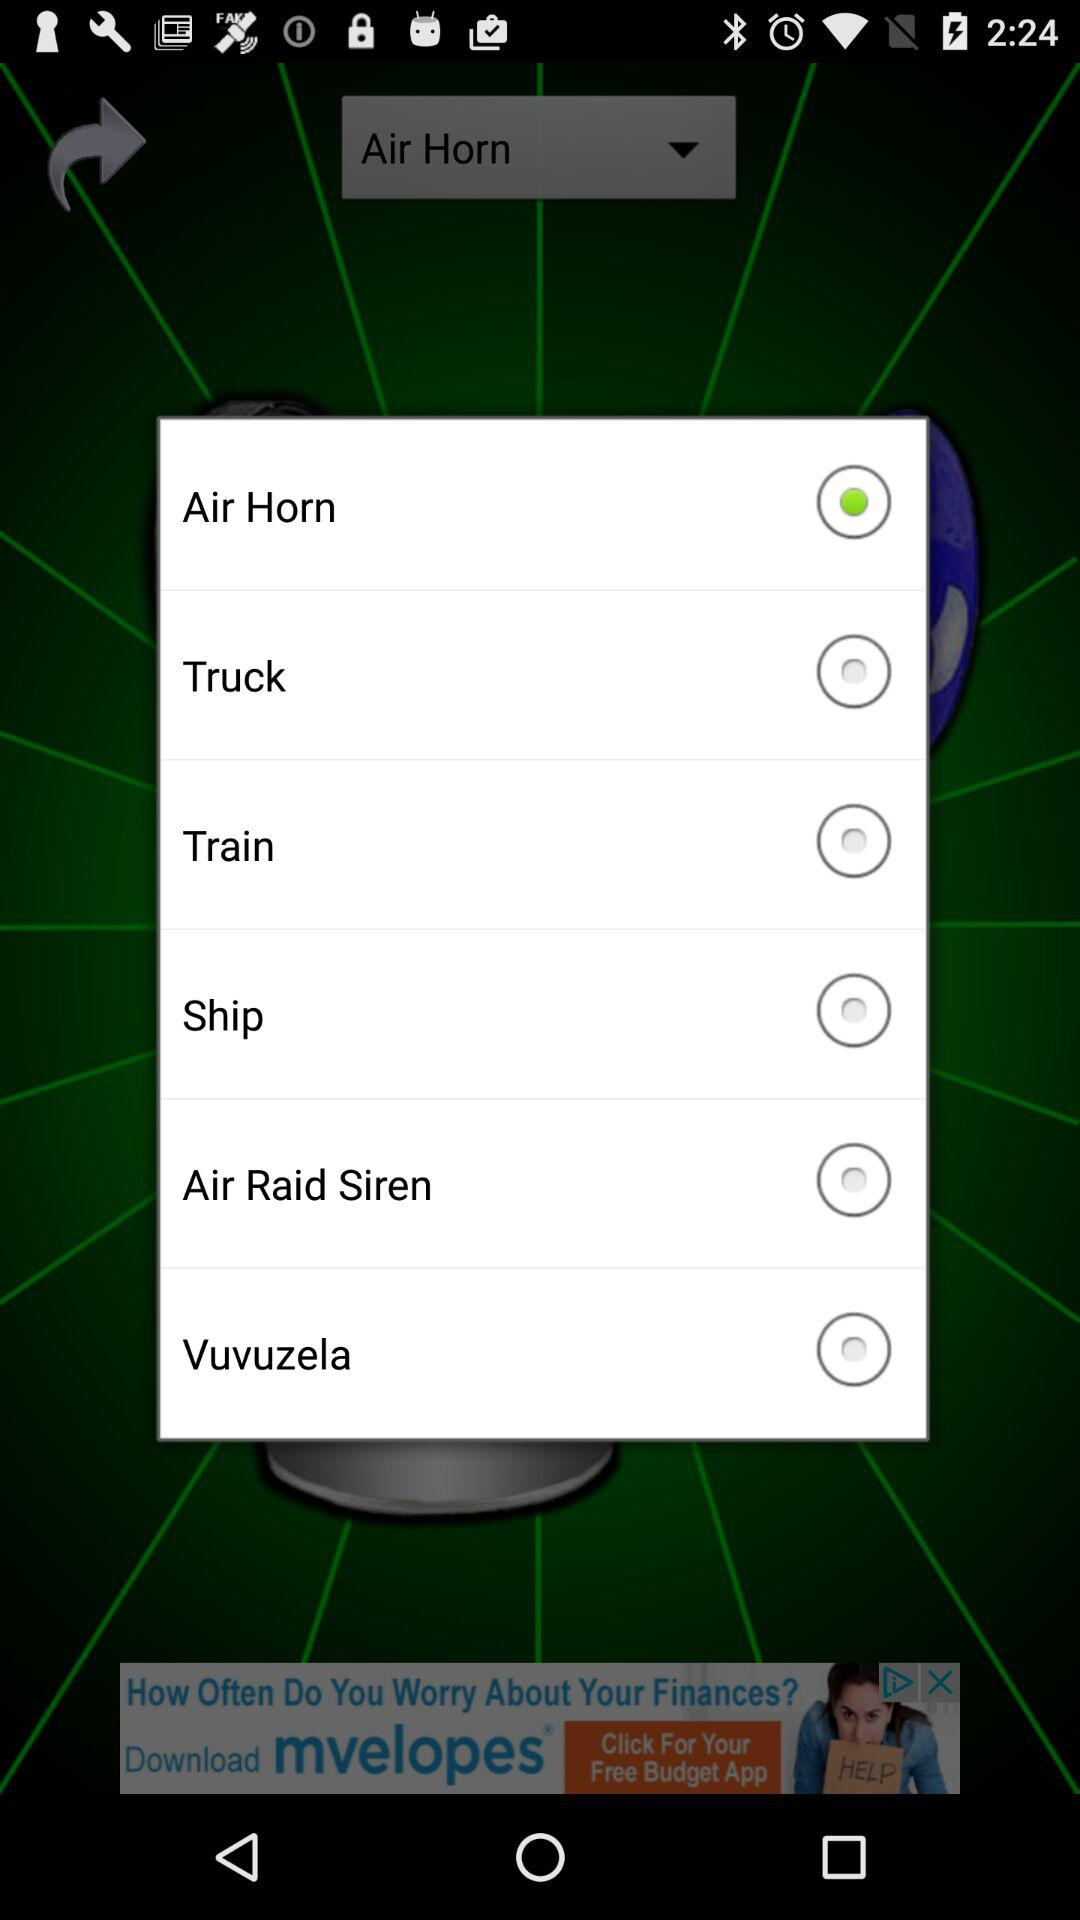What's the application's name?
When the provided information is insufficient, respond with <no answer>. <no answer> 